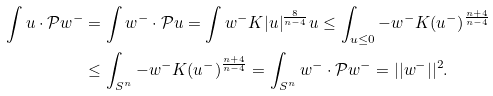<formula> <loc_0><loc_0><loc_500><loc_500>\int u \cdot \mathcal { P } w ^ { - } & = \int w ^ { - } \cdot \mathcal { P } u = \int w ^ { - } K | u | ^ { \frac { 8 } { n - 4 } } u \leq \int _ { u \leq 0 } - w ^ { - } K ( u ^ { - } ) ^ { \frac { n + 4 } { n - 4 } } \\ & \leq \int _ { S ^ { n } } - w ^ { - } K ( u ^ { - } ) ^ { \frac { n + 4 } { n - 4 } } = \int _ { S ^ { n } } w ^ { - } \cdot \mathcal { P } w ^ { - } = | | w ^ { - } | | ^ { 2 } .</formula> 